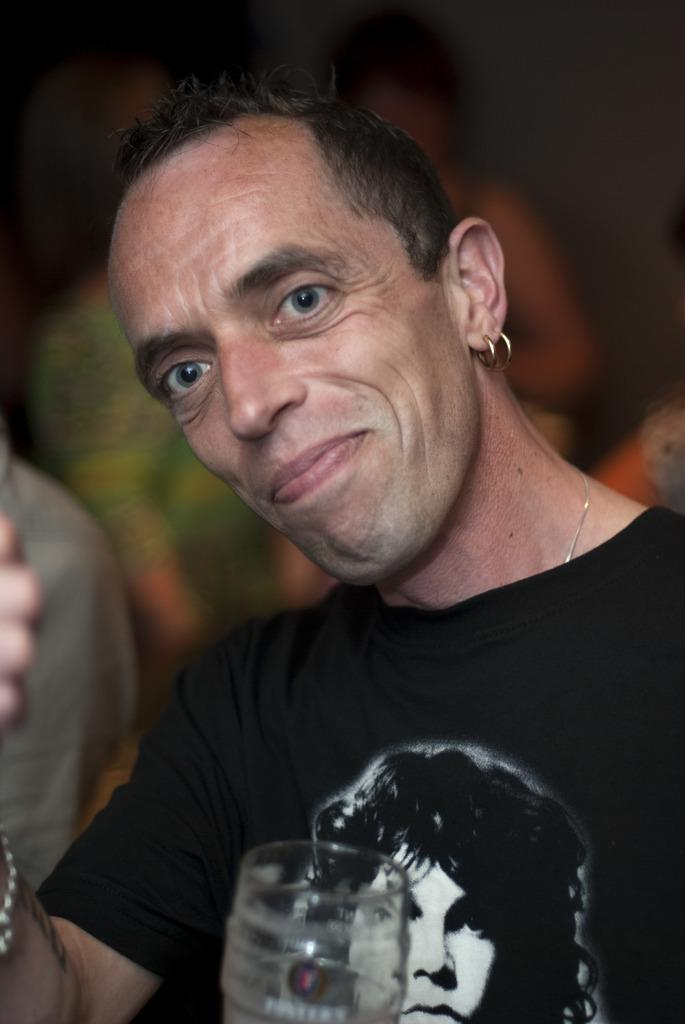How many people are in the image? There is a group of people in the image, but the exact number cannot be determined from the provided facts. What object can be seen in the image besides the people? There is a glass visible in the image. Can you describe the possible setting of the image? The image may have been taken in a restaurant, but this cannot be confirmed with certainty. What word is written on the square in the image? There is no square or word present in the image. 